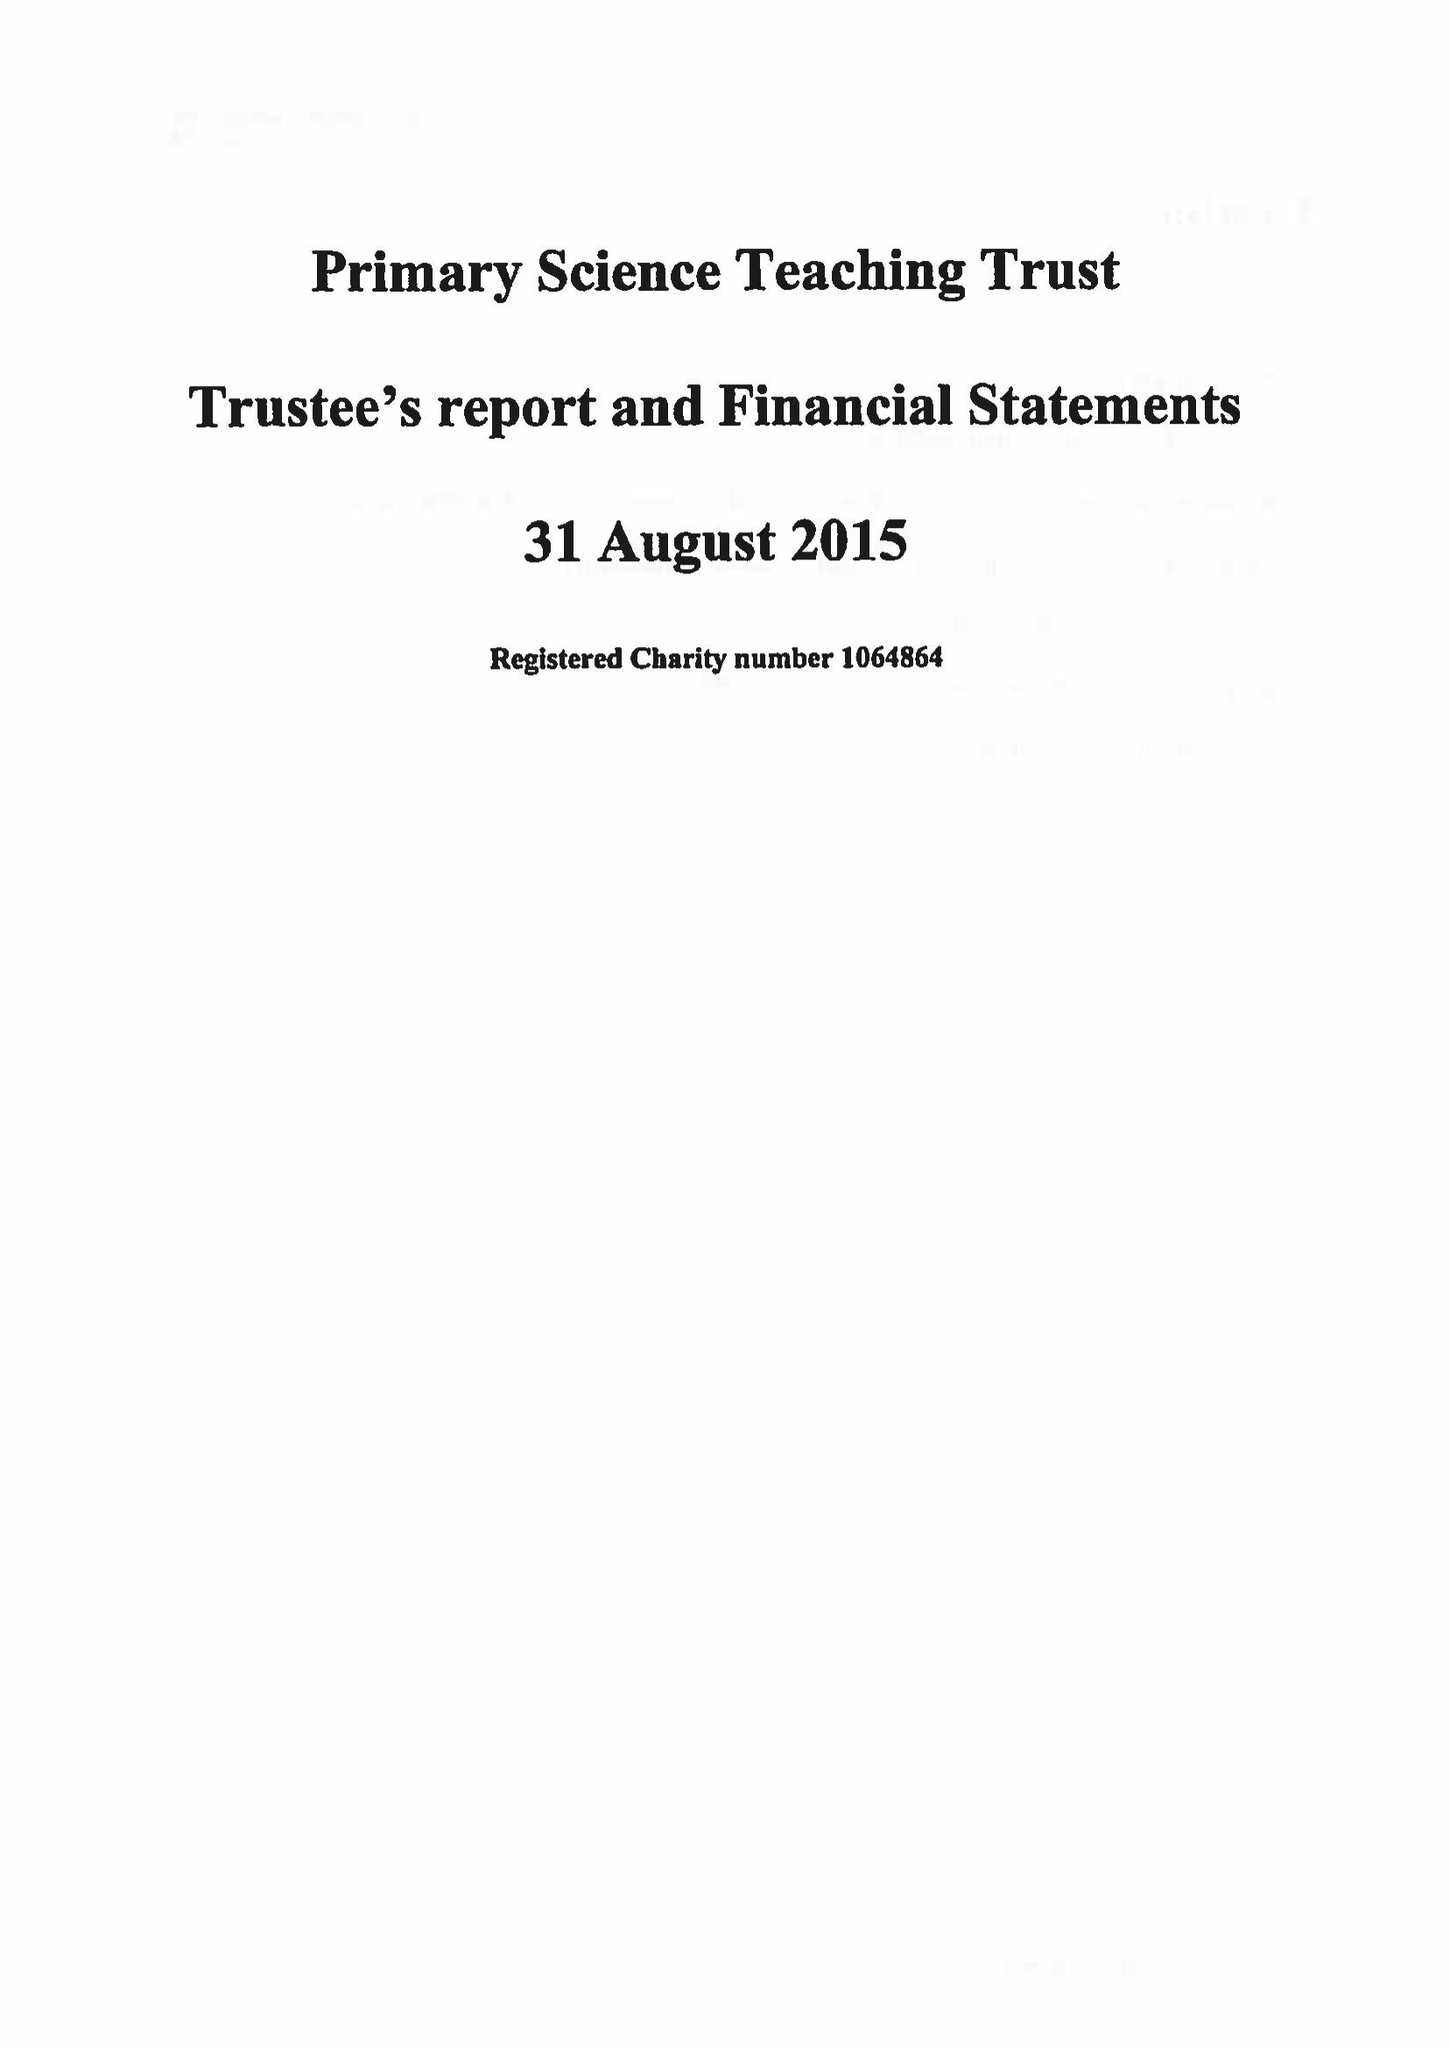What is the value for the spending_annually_in_british_pounds?
Answer the question using a single word or phrase. 1250218.00 